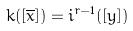<formula> <loc_0><loc_0><loc_500><loc_500>k ( [ \overline { x } ] ) = i ^ { r - 1 } ( [ y ] )</formula> 